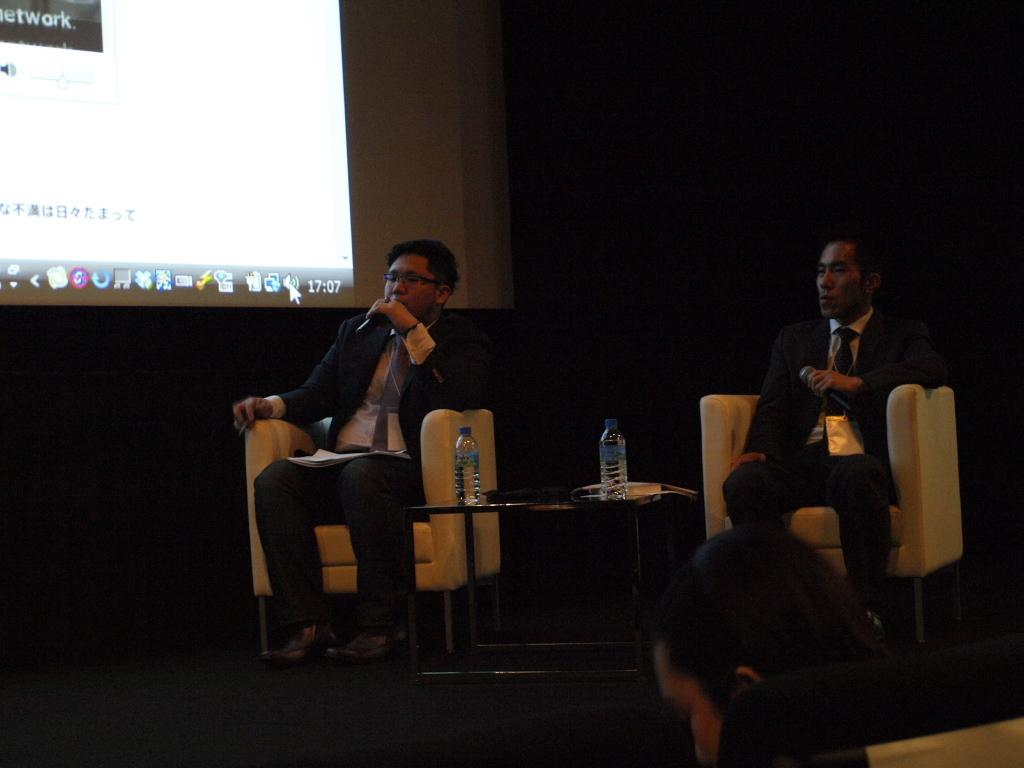How many people are sitting in the chairs in the image? There are three people sitting on chairs in the image. What is one person doing with their hand? One person is holding a microphone. What can be seen on the table in the image? There is a water bottle on the table. What is displayed on the wall in the image? A screen is displayed on the wall. What type of plant is being served at the feast in the image? There is no feast or plant present in the image. 